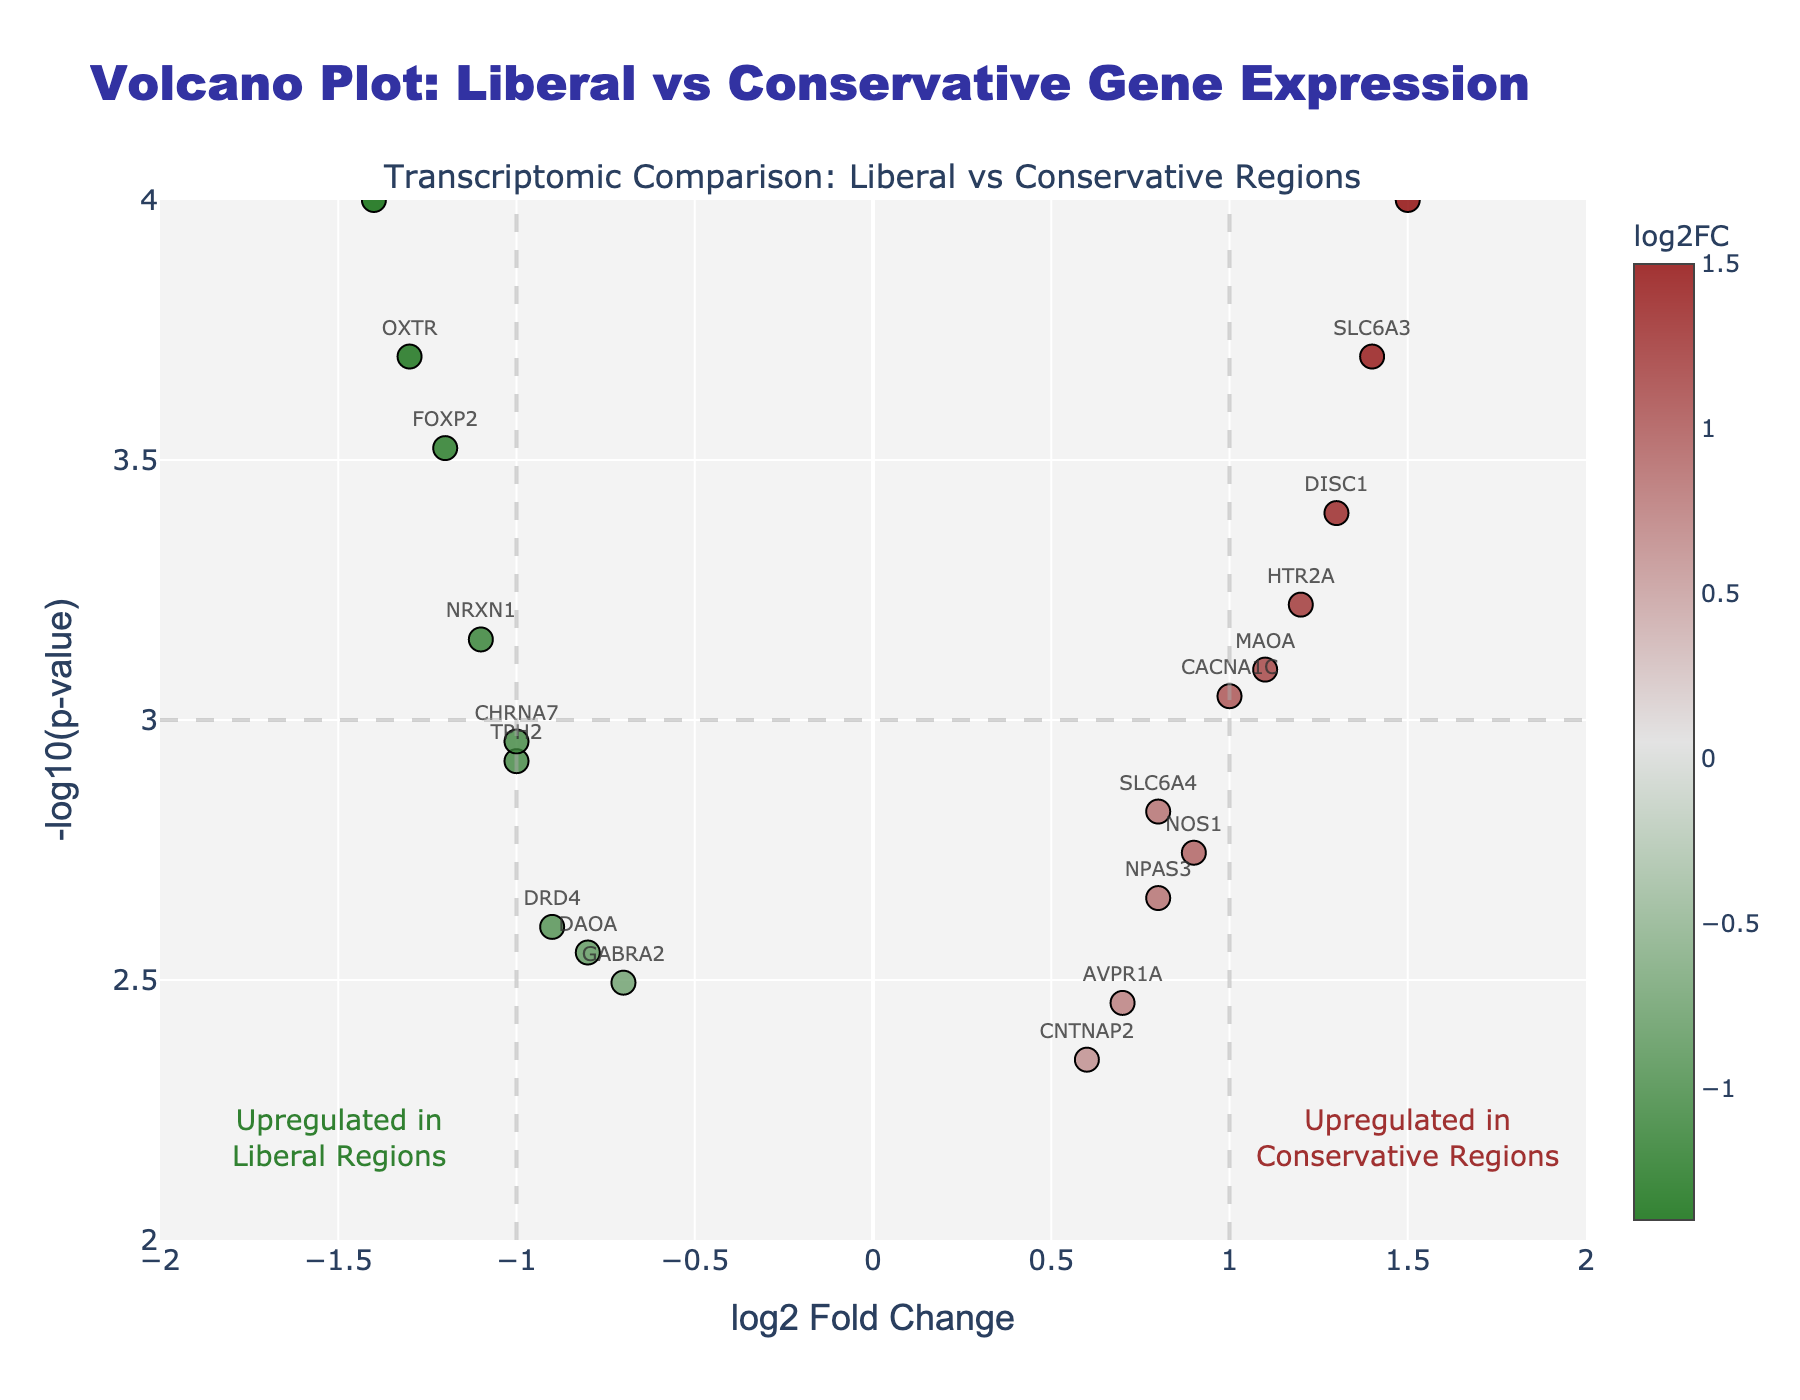What's the title of the figure? The title of the figure is displayed prominently at the top in bold, large font. It reads "Volcano Plot: Liberal vs Conservative Gene Expression".
Answer: Volcano Plot: Liberal vs Conservative Gene Expression What does the x-axis represent? The label on the x-axis indicates that it represents the "log2 Fold Change" of gene expression between the two regions.
Answer: log2 Fold Change How many genes are significantly upregulated in conservative regions? Significant upregulation can be determined by looking at points with a log2 Fold Change greater than 1 and a -log10(p-value) above the significance threshold line at y = 3. Since "significantly" often refers to a log2 Fold Change > 1 and p-value < 0.001, we have genes like COMT and SLC6A3.
Answer: 2 Which gene has the highest log2 Fold Change? By looking at the x-axis values, we find that COMT has the highest log2 Fold Change at 1.5.
Answer: COMT What does a point in the lower left quadrant represent? A point in the lower left quadrant has a negative log2 Fold Change and a lower -log10(p-value), indicating that the gene is downregulated in liberal regions but is not statistically significant.
Answer: Downregulation in liberal regions, not significant Between MAOA and OXTR, which gene has a higher p-value? Based on the -log10(p-value) on the y-axis, OXTR (y ≈ 3.70) has a higher -log10(p-value) than MAOA (y ≈ 3.10), meaning OXTR has a lower p-value.
Answer: OXTR What can be inferred about genes positioned at the extreme ends of the log2 Fold Change axis? Genes at extreme ends, like COMT (1.5) and BDNF (-1.4), show the highest levels of differential expression, indicating strong upregulation in either conservative or liberal regions, respectively.
Answer: Highly differentially expressed Which gene is both significantly upregulated in conservatiive regions and represented near the center top of the plot? SLC6A4 is near the center top with log2 Fold Change ≈ 0.8 and -log10(p-value) ≈ 2.8, indicating it is notably expressed but not at extreme fold changes.
Answer: SLC6A4 How does the color of the points on the plot help interpret the data? Points are colored according to their log2 Fold Change values using a linear gradient: green for downregulated genes, grey for moderately changed genes, and red for upregulated genes. This helps easily identify gene expression trends visually.
Answer: Color gradient indicates fold change 